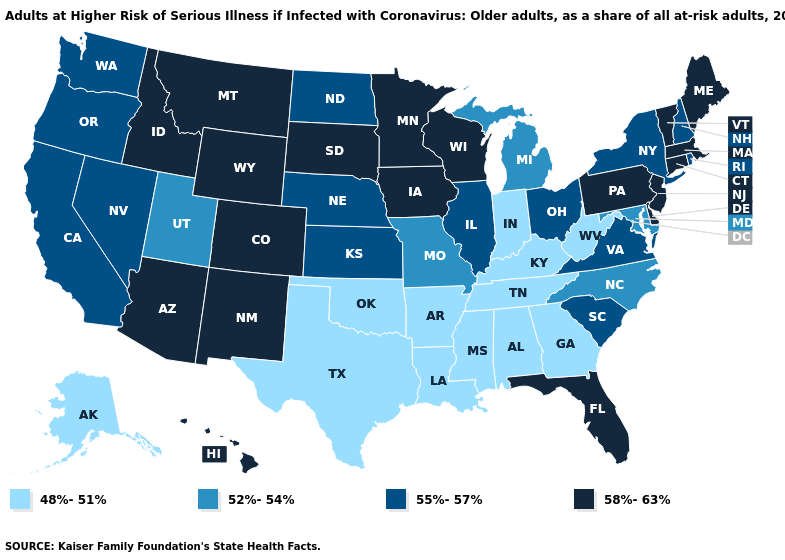What is the value of Florida?
Concise answer only. 58%-63%. What is the value of New Mexico?
Write a very short answer. 58%-63%. Does the first symbol in the legend represent the smallest category?
Keep it brief. Yes. Does Connecticut have a higher value than New York?
Short answer required. Yes. Among the states that border Tennessee , which have the highest value?
Keep it brief. Virginia. What is the value of Wyoming?
Quick response, please. 58%-63%. Name the states that have a value in the range 48%-51%?
Give a very brief answer. Alabama, Alaska, Arkansas, Georgia, Indiana, Kentucky, Louisiana, Mississippi, Oklahoma, Tennessee, Texas, West Virginia. Does the map have missing data?
Write a very short answer. No. What is the highest value in states that border Vermont?
Write a very short answer. 58%-63%. Does Indiana have the lowest value in the MidWest?
Give a very brief answer. Yes. What is the value of North Dakota?
Quick response, please. 55%-57%. What is the value of Virginia?
Be succinct. 55%-57%. Which states have the highest value in the USA?
Answer briefly. Arizona, Colorado, Connecticut, Delaware, Florida, Hawaii, Idaho, Iowa, Maine, Massachusetts, Minnesota, Montana, New Jersey, New Mexico, Pennsylvania, South Dakota, Vermont, Wisconsin, Wyoming. Does Alaska have the lowest value in the West?
Write a very short answer. Yes. 